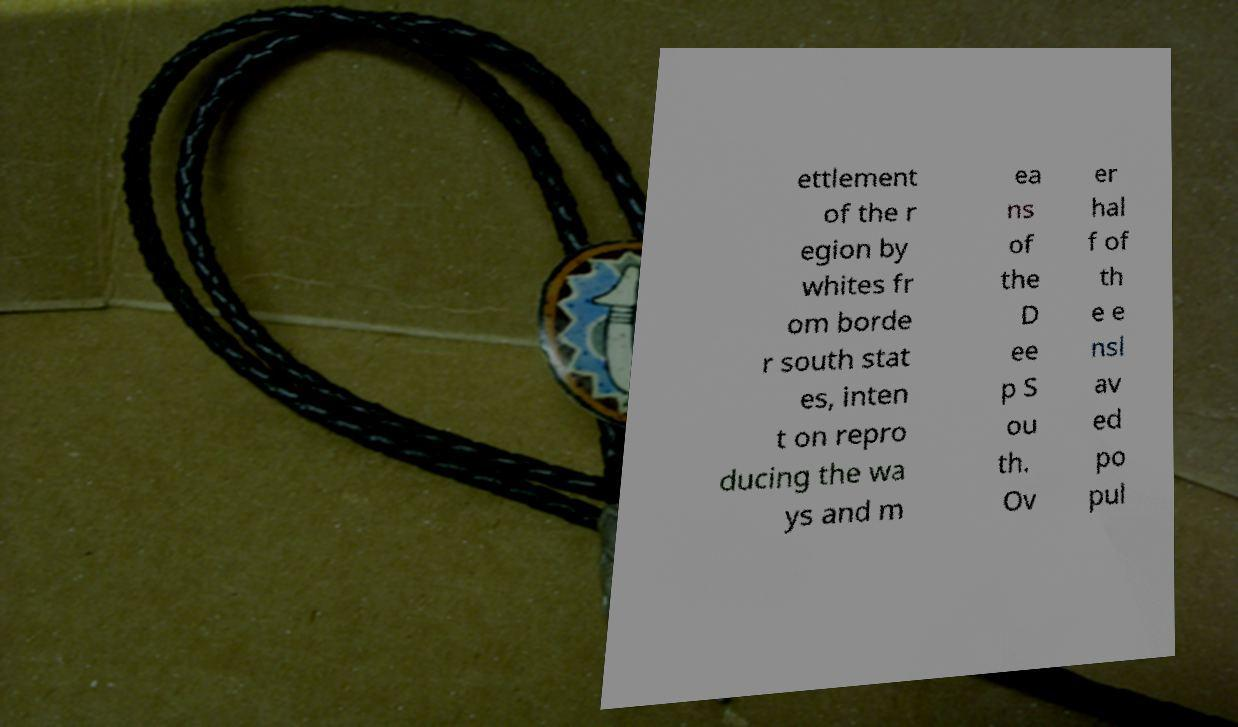Could you assist in decoding the text presented in this image and type it out clearly? ettlement of the r egion by whites fr om borde r south stat es, inten t on repro ducing the wa ys and m ea ns of the D ee p S ou th. Ov er hal f of th e e nsl av ed po pul 